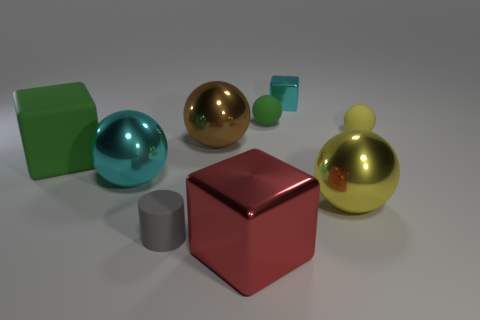What shape is the object that is to the left of the small gray object and in front of the large green thing?
Your answer should be compact. Sphere. Is there a thing that has the same size as the cyan shiny ball?
Offer a very short reply. Yes. There is a cyan metallic thing behind the large brown sphere; is it the same shape as the red object?
Your answer should be compact. Yes. Do the small green object and the yellow metal thing have the same shape?
Offer a very short reply. Yes. Are there any large yellow objects of the same shape as the small green matte thing?
Offer a terse response. Yes. There is a tiny matte object in front of the small matte thing to the right of the yellow metal ball; what is its shape?
Offer a terse response. Cylinder. What is the color of the block behind the tiny yellow ball?
Your response must be concise. Cyan. What size is the gray cylinder that is the same material as the small green object?
Offer a terse response. Small. There is a green thing that is the same shape as the brown object; what is its size?
Give a very brief answer. Small. Are any small metallic cylinders visible?
Keep it short and to the point. No. 